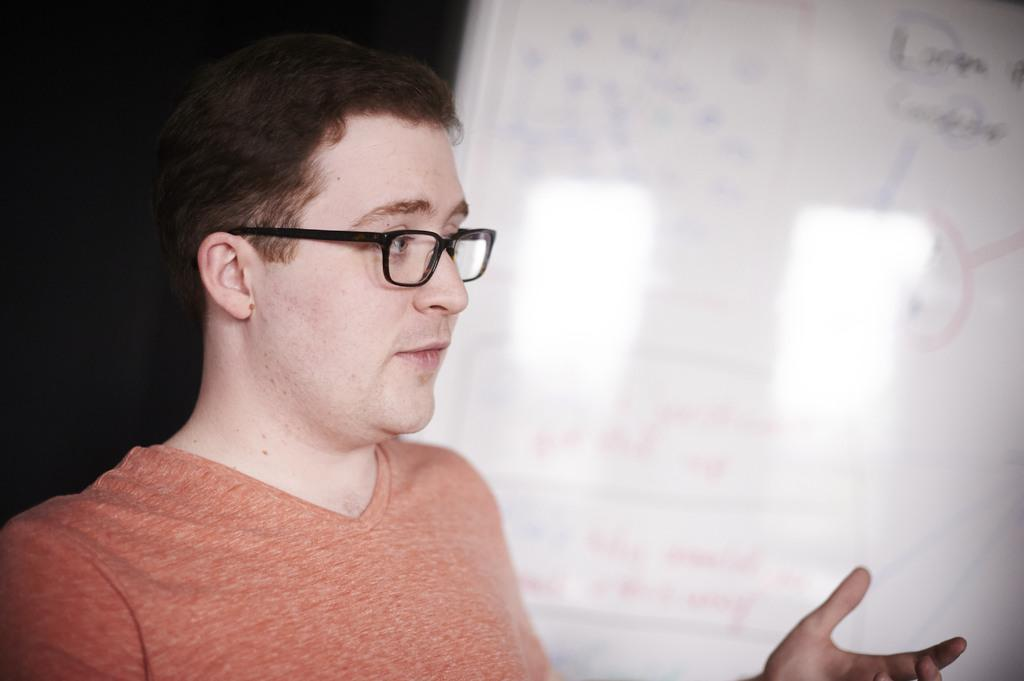What is the main subject of the image? There is a person in the image. What object is located at the rightmost part of the image? There is a whiteboard at the rightmost part of the image. Can you see a dog taking a bath in the image? No, there is no dog or bath present in the image. What type of lip product is the person wearing in the image? There is no lip product visible on the person in the image. 